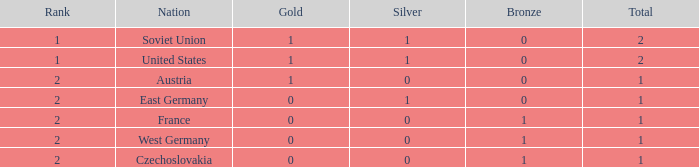What is the status of the team with 0 gold and below 0 silvers? None. 